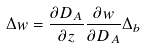Convert formula to latex. <formula><loc_0><loc_0><loc_500><loc_500>\Delta w = \frac { \partial D _ { A } } { \partial z } \frac { \partial w } { \partial D _ { A } } \Delta _ { b }</formula> 